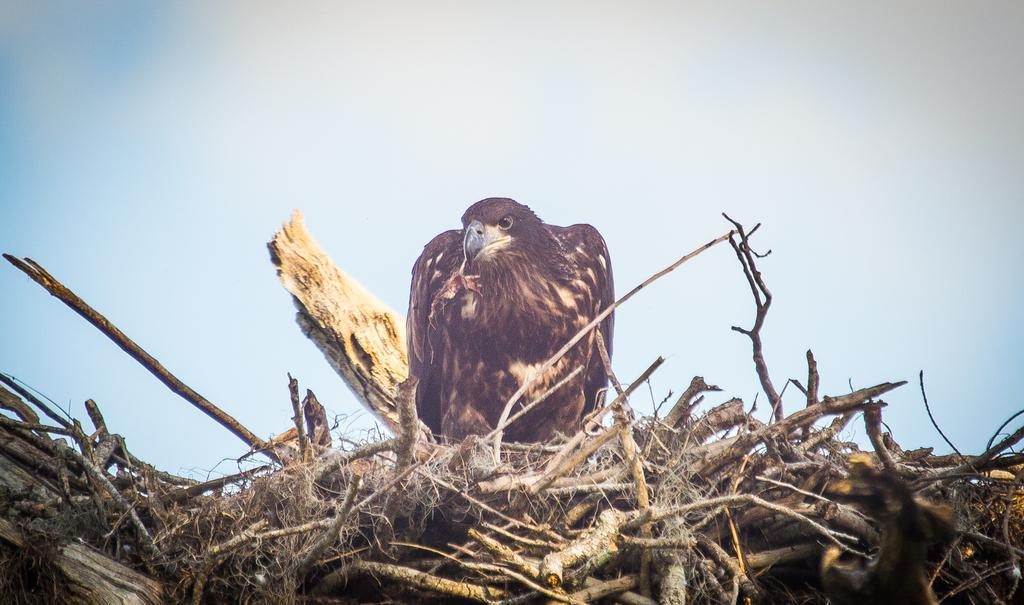What animal is the main subject of the image? There is an eagle in the image. Where is the eagle located in the image? The eagle is standing on the branches of a tree. What can be seen in the background of the image? The sky is visible in the background of the image. What type of experience does the deer have in the image? There is no deer present in the image, so it is not possible to discuss the deer's experience. 